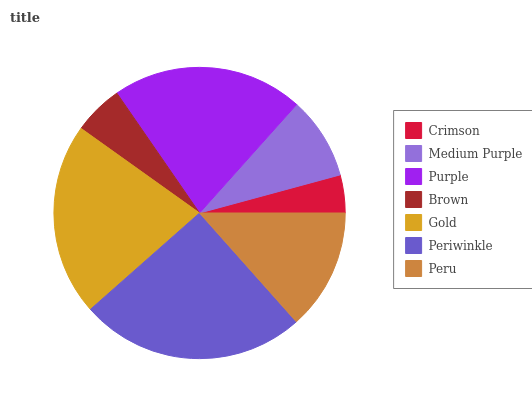Is Crimson the minimum?
Answer yes or no. Yes. Is Periwinkle the maximum?
Answer yes or no. Yes. Is Medium Purple the minimum?
Answer yes or no. No. Is Medium Purple the maximum?
Answer yes or no. No. Is Medium Purple greater than Crimson?
Answer yes or no. Yes. Is Crimson less than Medium Purple?
Answer yes or no. Yes. Is Crimson greater than Medium Purple?
Answer yes or no. No. Is Medium Purple less than Crimson?
Answer yes or no. No. Is Peru the high median?
Answer yes or no. Yes. Is Peru the low median?
Answer yes or no. Yes. Is Gold the high median?
Answer yes or no. No. Is Gold the low median?
Answer yes or no. No. 